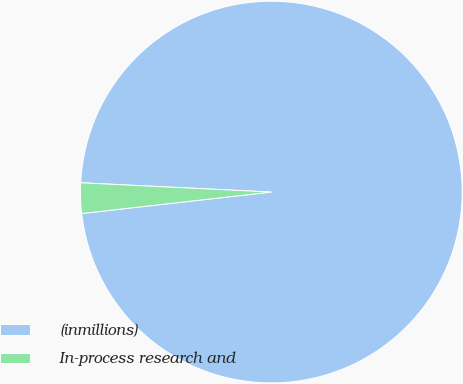Convert chart to OTSL. <chart><loc_0><loc_0><loc_500><loc_500><pie_chart><fcel>(inmillions)<fcel>In-process research and<nl><fcel>97.43%<fcel>2.57%<nl></chart> 